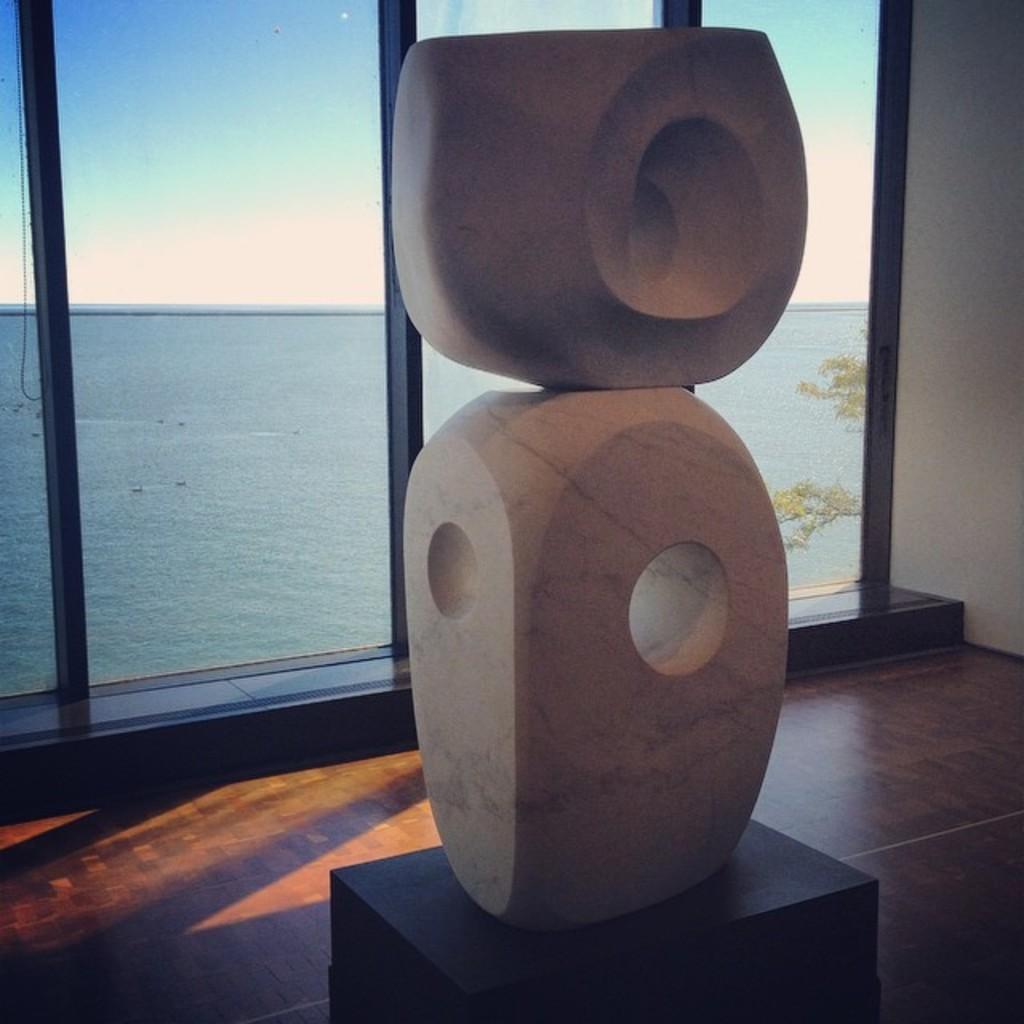Describe this image in one or two sentences. In this picture, they are looking like some architecture structures on an object and the object on the wooden floor. Behind the architectural structures there is a glass window, a tree, sea and the sky. 